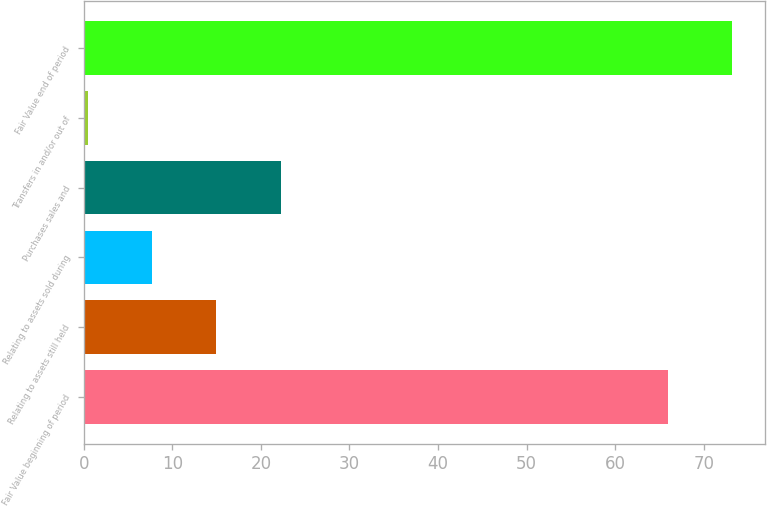Convert chart to OTSL. <chart><loc_0><loc_0><loc_500><loc_500><bar_chart><fcel>Fair Value beginning of period<fcel>Relating to assets still held<fcel>Relating to assets sold during<fcel>Purchases sales and<fcel>Transfers in and/or out of<fcel>Fair Value end of period<nl><fcel>66<fcel>14.98<fcel>7.73<fcel>22.23<fcel>0.48<fcel>73.25<nl></chart> 